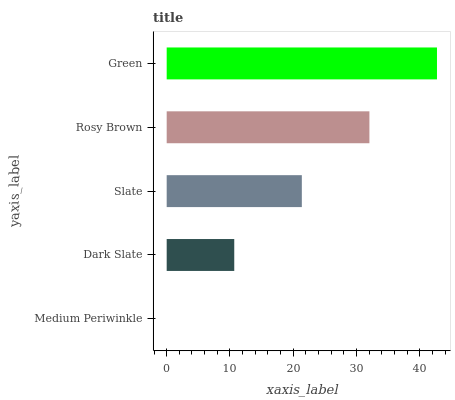Is Medium Periwinkle the minimum?
Answer yes or no. Yes. Is Green the maximum?
Answer yes or no. Yes. Is Dark Slate the minimum?
Answer yes or no. No. Is Dark Slate the maximum?
Answer yes or no. No. Is Dark Slate greater than Medium Periwinkle?
Answer yes or no. Yes. Is Medium Periwinkle less than Dark Slate?
Answer yes or no. Yes. Is Medium Periwinkle greater than Dark Slate?
Answer yes or no. No. Is Dark Slate less than Medium Periwinkle?
Answer yes or no. No. Is Slate the high median?
Answer yes or no. Yes. Is Slate the low median?
Answer yes or no. Yes. Is Medium Periwinkle the high median?
Answer yes or no. No. Is Dark Slate the low median?
Answer yes or no. No. 